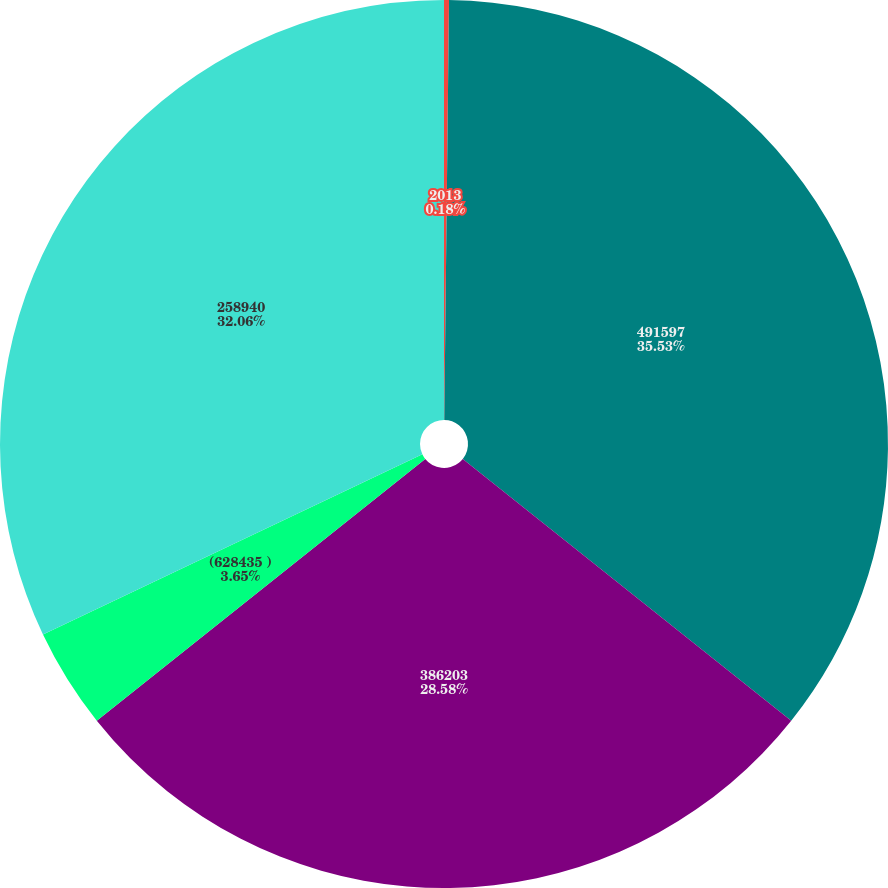<chart> <loc_0><loc_0><loc_500><loc_500><pie_chart><fcel>2013<fcel>491597<fcel>386203<fcel>(628435 )<fcel>258940<nl><fcel>0.18%<fcel>35.53%<fcel>28.58%<fcel>3.65%<fcel>32.06%<nl></chart> 